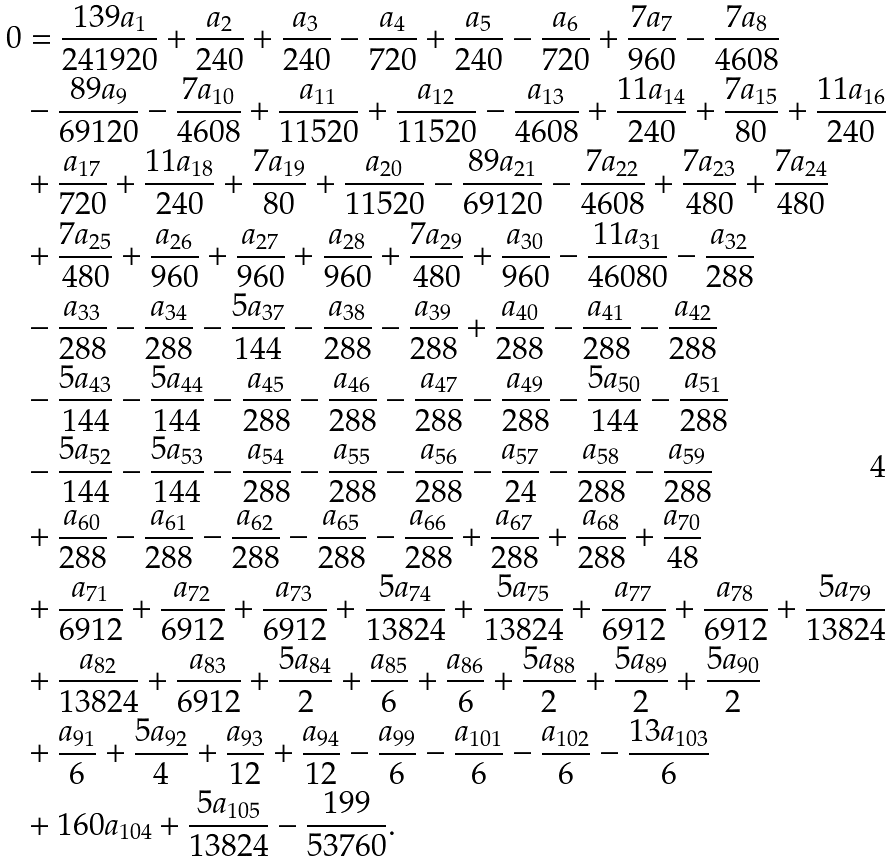Convert formula to latex. <formula><loc_0><loc_0><loc_500><loc_500>0 & = \frac { 1 3 9 a _ { 1 } } { 2 4 1 9 2 0 } + \frac { a _ { 2 } } { 2 4 0 } + \frac { a _ { 3 } } { 2 4 0 } - \frac { a _ { 4 } } { 7 2 0 } + \frac { a _ { 5 } } { 2 4 0 } - \frac { a _ { 6 } } { 7 2 0 } + \frac { 7 a _ { 7 } } { 9 6 0 } - \frac { 7 a _ { 8 } } { 4 6 0 8 } \\ & - \frac { 8 9 a _ { 9 } } { 6 9 1 2 0 } - \frac { 7 a _ { 1 0 } } { 4 6 0 8 } + \frac { a _ { 1 1 } } { 1 1 5 2 0 } + \frac { a _ { 1 2 } } { 1 1 5 2 0 } - \frac { a _ { 1 3 } } { 4 6 0 8 } + \frac { 1 1 a _ { 1 4 } } { 2 4 0 } + \frac { 7 a _ { 1 5 } } { 8 0 } + \frac { 1 1 a _ { 1 6 } } { 2 4 0 } \\ & + \frac { a _ { 1 7 } } { 7 2 0 } + \frac { 1 1 a _ { 1 8 } } { 2 4 0 } + \frac { 7 a _ { 1 9 } } { 8 0 } + \frac { a _ { 2 0 } } { 1 1 5 2 0 } - \frac { 8 9 a _ { 2 1 } } { 6 9 1 2 0 } - \frac { 7 a _ { 2 2 } } { 4 6 0 8 } + \frac { 7 a _ { 2 3 } } { 4 8 0 } + \frac { 7 a _ { 2 4 } } { 4 8 0 } \\ & + \frac { 7 a _ { 2 5 } } { 4 8 0 } + \frac { a _ { 2 6 } } { 9 6 0 } + \frac { a _ { 2 7 } } { 9 6 0 } + \frac { a _ { 2 8 } } { 9 6 0 } + \frac { 7 a _ { 2 9 } } { 4 8 0 } + \frac { a _ { 3 0 } } { 9 6 0 } - \frac { 1 1 a _ { 3 1 } } { 4 6 0 8 0 } - \frac { a _ { 3 2 } } { 2 8 8 } \\ & - \frac { a _ { 3 3 } } { 2 8 8 } - \frac { a _ { 3 4 } } { 2 8 8 } - \frac { 5 a _ { 3 7 } } { 1 4 4 } - \frac { a _ { 3 8 } } { 2 8 8 } - \frac { a _ { 3 9 } } { 2 8 8 } + \frac { a _ { 4 0 } } { 2 8 8 } - \frac { a _ { 4 1 } } { 2 8 8 } - \frac { a _ { 4 2 } } { 2 8 8 } \\ & - \frac { 5 a _ { 4 3 } } { 1 4 4 } - \frac { 5 a _ { 4 4 } } { 1 4 4 } - \frac { a _ { 4 5 } } { 2 8 8 } - \frac { a _ { 4 6 } } { 2 8 8 } - \frac { a _ { 4 7 } } { 2 8 8 } - \frac { a _ { 4 9 } } { 2 8 8 } - \frac { 5 a _ { 5 0 } } { 1 4 4 } - \frac { a _ { 5 1 } } { 2 8 8 } \\ & - \frac { 5 a _ { 5 2 } } { 1 4 4 } - \frac { 5 a _ { 5 3 } } { 1 4 4 } - \frac { a _ { 5 4 } } { 2 8 8 } - \frac { a _ { 5 5 } } { 2 8 8 } - \frac { a _ { 5 6 } } { 2 8 8 } - \frac { a _ { 5 7 } } { 2 4 } - \frac { a _ { 5 8 } } { 2 8 8 } - \frac { a _ { 5 9 } } { 2 8 8 } \\ & + \frac { a _ { 6 0 } } { 2 8 8 } - \frac { a _ { 6 1 } } { 2 8 8 } - \frac { a _ { 6 2 } } { 2 8 8 } - \frac { a _ { 6 5 } } { 2 8 8 } - \frac { a _ { 6 6 } } { 2 8 8 } + \frac { a _ { 6 7 } } { 2 8 8 } + \frac { a _ { 6 8 } } { 2 8 8 } + \frac { a _ { 7 0 } } { 4 8 } \\ & + \frac { a _ { 7 1 } } { 6 9 1 2 } + \frac { a _ { 7 2 } } { 6 9 1 2 } + \frac { a _ { 7 3 } } { 6 9 1 2 } + \frac { 5 a _ { 7 4 } } { 1 3 8 2 4 } + \frac { 5 a _ { 7 5 } } { 1 3 8 2 4 } + \frac { a _ { 7 7 } } { 6 9 1 2 } + \frac { a _ { 7 8 } } { 6 9 1 2 } + \frac { 5 a _ { 7 9 } } { 1 3 8 2 4 } \\ & + \frac { a _ { 8 2 } } { 1 3 8 2 4 } + \frac { a _ { 8 3 } } { 6 9 1 2 } + \frac { 5 a _ { 8 4 } } { 2 } + \frac { a _ { 8 5 } } { 6 } + \frac { a _ { 8 6 } } { 6 } + \frac { 5 a _ { 8 8 } } { 2 } + \frac { 5 a _ { 8 9 } } { 2 } + \frac { 5 a _ { 9 0 } } { 2 } \\ & + \frac { a _ { 9 1 } } { 6 } + \frac { 5 a _ { 9 2 } } { 4 } + \frac { a _ { 9 3 } } { 1 2 } + \frac { a _ { 9 4 } } { 1 2 } - \frac { a _ { 9 9 } } { 6 } - \frac { a _ { 1 0 1 } } { 6 } - \frac { a _ { 1 0 2 } } { 6 } - \frac { 1 3 a _ { 1 0 3 } } { 6 } \\ & + 1 6 0 a _ { 1 0 4 } + \frac { 5 a _ { 1 0 5 } } { 1 3 8 2 4 } - \frac { 1 9 9 } { 5 3 7 6 0 } .</formula> 